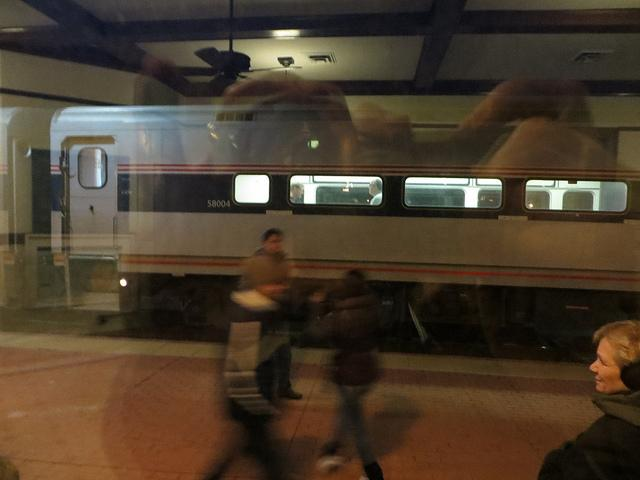How many people are walking around in the train station? three 